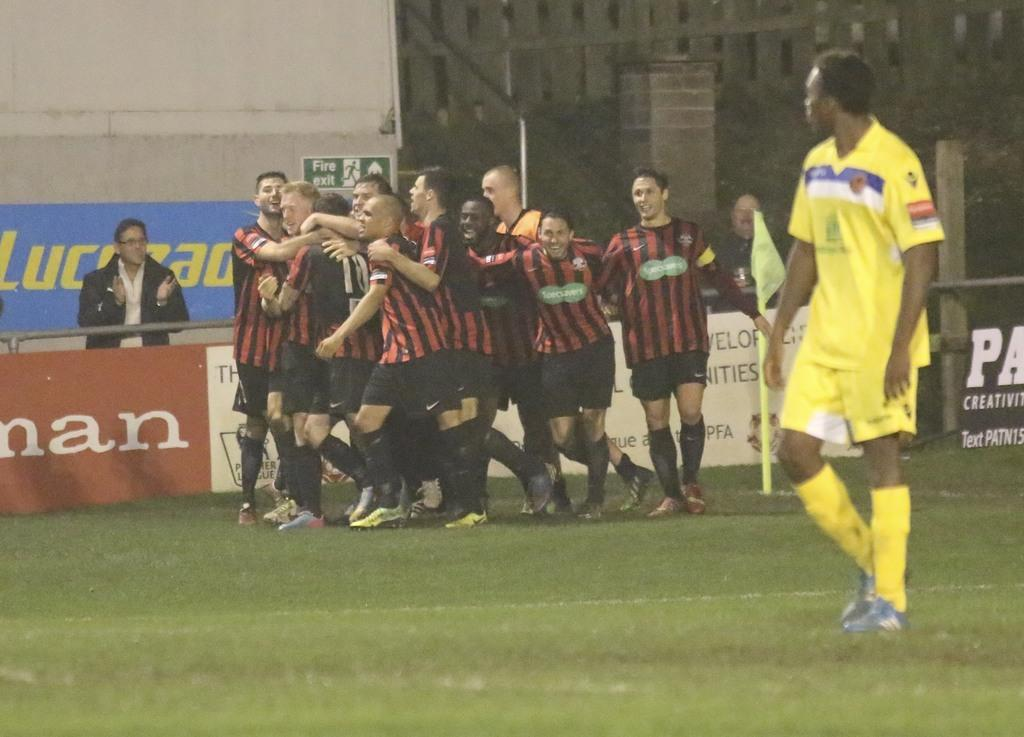<image>
Give a short and clear explanation of the subsequent image. A crowd of players is right near the little green for the fire exit. 